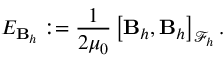<formula> <loc_0><loc_0><loc_500><loc_500>E _ { B _ { h } } \colon = \frac { 1 } { 2 \mu _ { 0 } } \left [ B _ { h } , B _ { h } \right ] _ { \mathcal { F } _ { h } } .</formula> 